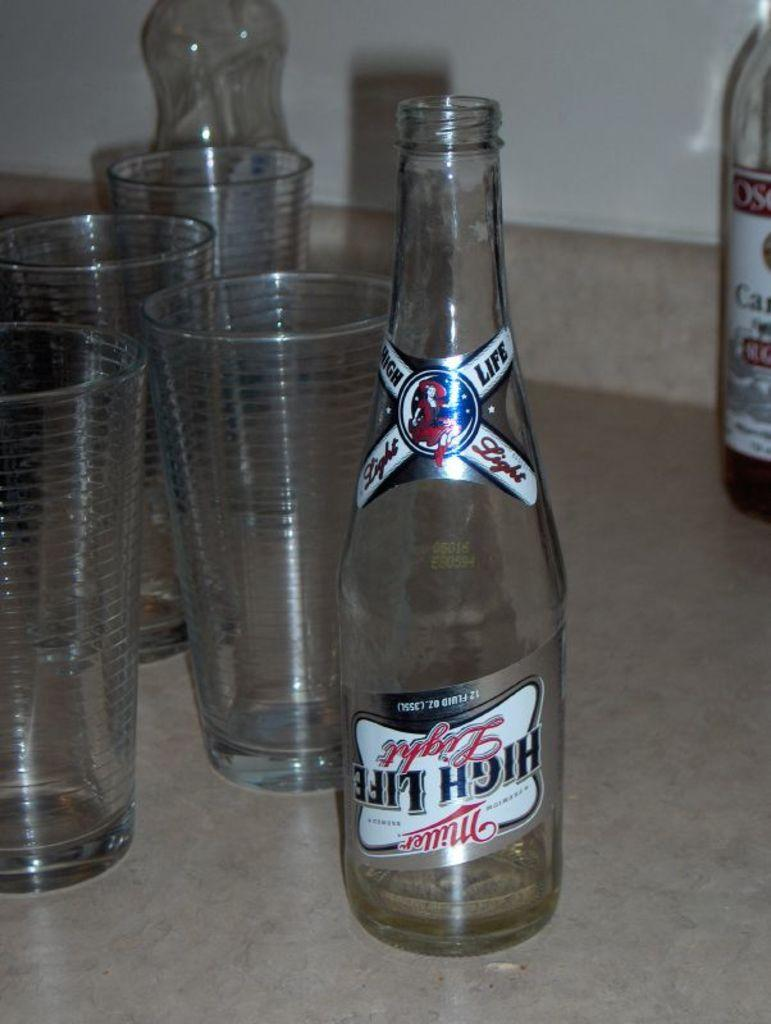<image>
Share a concise interpretation of the image provided. An empty bottle of Miller High Life Light sits on a counter near several empty glasses. 